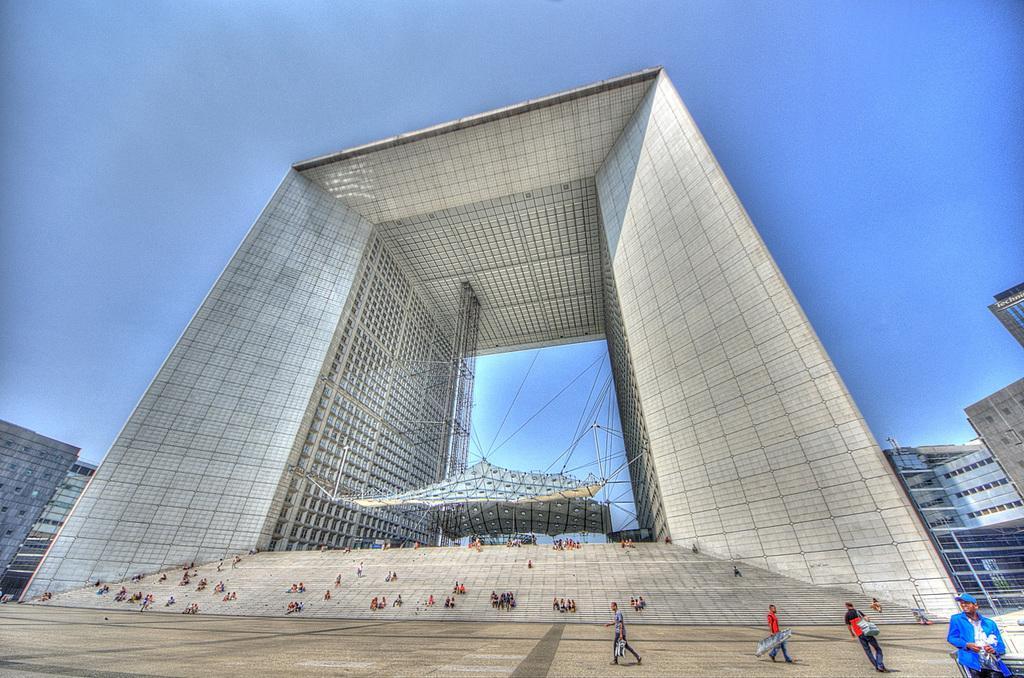How would you summarize this image in a sentence or two? In the picture I can see people among them some are walking on the ground and some are on steps, In the background I can see buildings, the sky and some other objects on the ground. 